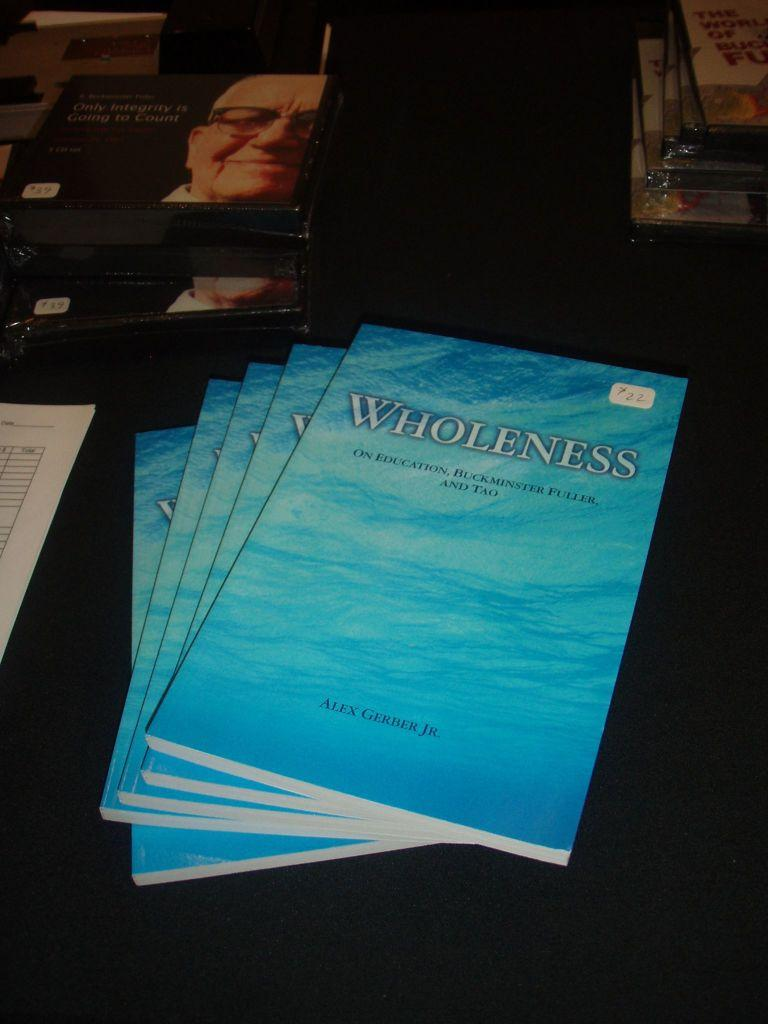<image>
Summarize the visual content of the image. Stack of pamphlets called Wholeness and written by Alex Gerber Jr. 